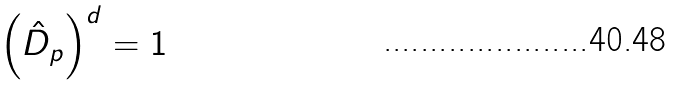Convert formula to latex. <formula><loc_0><loc_0><loc_500><loc_500>\left ( \hat { D } _ { p } \right ) ^ { d } = 1</formula> 